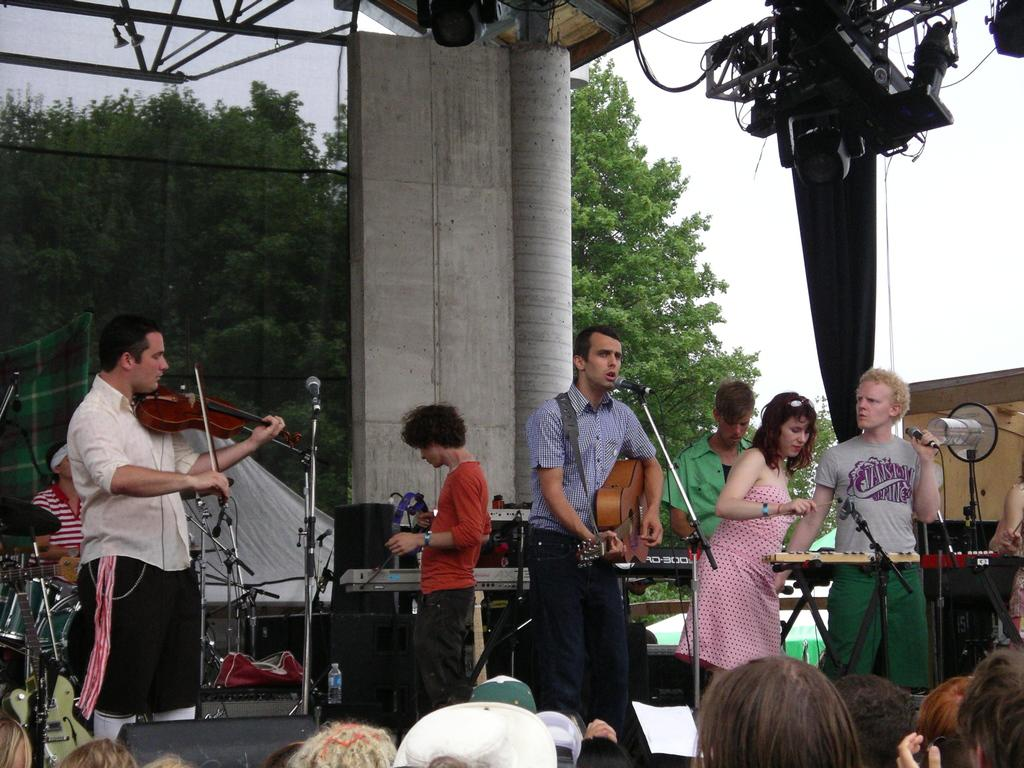What are the persons in the image doing? The persons in the image are playing musical instruments. What can be seen in the background of the image? There is a pillar, a tree, and the sky visible in the background of the image. Can you tell me how many boys are playing musical instruments in the image? The provided facts do not mention the gender of the persons playing musical instruments, so it is not possible to determine the number of boys in the image. What type of bulb is illuminating the tree in the image? There is no mention of a bulb or any form of illumination in the image, so it is not possible to answer this question. 